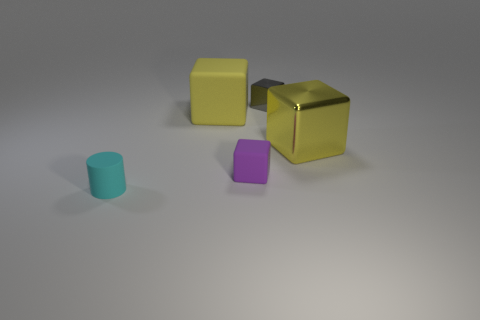What number of other objects are the same color as the large matte block?
Your answer should be very brief. 1. The big metallic object that is the same shape as the tiny gray object is what color?
Make the answer very short. Yellow. Is there any other thing that is the same shape as the cyan rubber thing?
Ensure brevity in your answer.  No. How many blocks are large yellow metal things or purple metal objects?
Make the answer very short. 1. There is a small purple matte object; what shape is it?
Give a very brief answer. Cube. Are there any big yellow blocks in front of the purple block?
Your response must be concise. No. Is the material of the tiny purple cube the same as the large yellow thing to the right of the purple matte cube?
Your answer should be compact. No. There is a yellow object right of the tiny purple matte cube; is its shape the same as the tiny shiny thing?
Offer a terse response. Yes. How many big yellow things are the same material as the gray cube?
Make the answer very short. 1. How many objects are objects that are right of the purple cube or large yellow rubber blocks?
Provide a short and direct response. 3. 